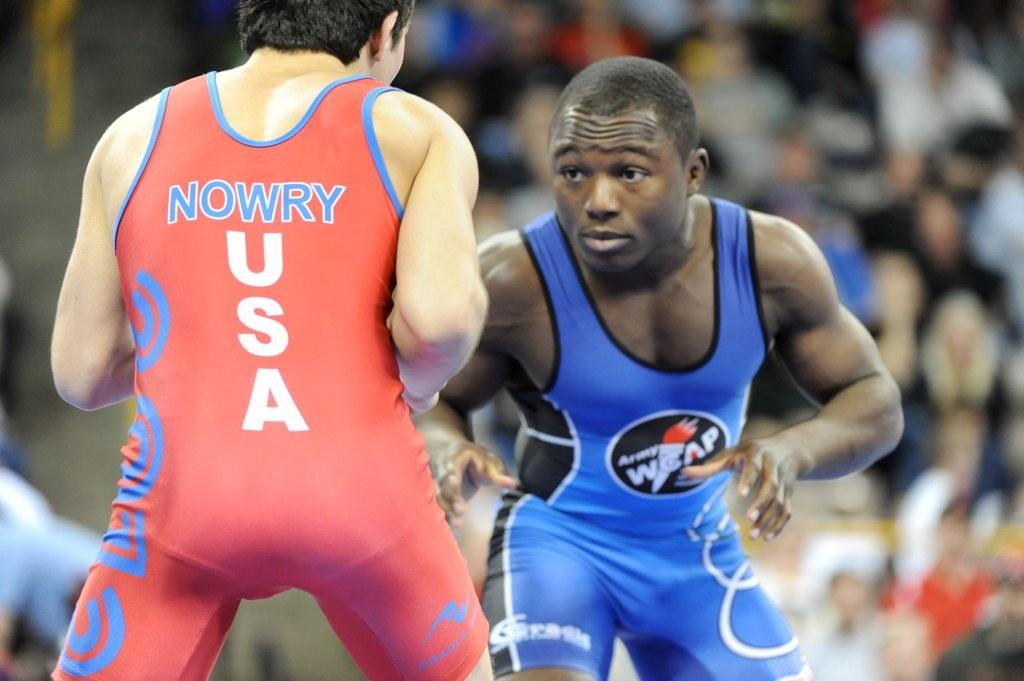<image>
Offer a succinct explanation of the picture presented. A USA wrestler's shirt says Nowry on the back. 